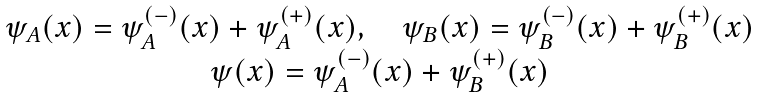Convert formula to latex. <formula><loc_0><loc_0><loc_500><loc_500>\begin{array} { c } { { \psi _ { A } ( x ) = \psi _ { A } ^ { \left ( - \right ) } ( x ) + \psi _ { A } ^ { \left ( + \right ) } ( x ) , \quad \psi _ { B } ( x ) = \psi _ { B } ^ { \left ( - \right ) } ( x ) + \psi _ { B } ^ { \left ( + \right ) } ( x ) } } \\ { { \psi ( x ) = \psi _ { A } ^ { \left ( - \right ) } ( x ) + \psi _ { B } ^ { \left ( + \right ) } ( x ) } } \end{array}</formula> 